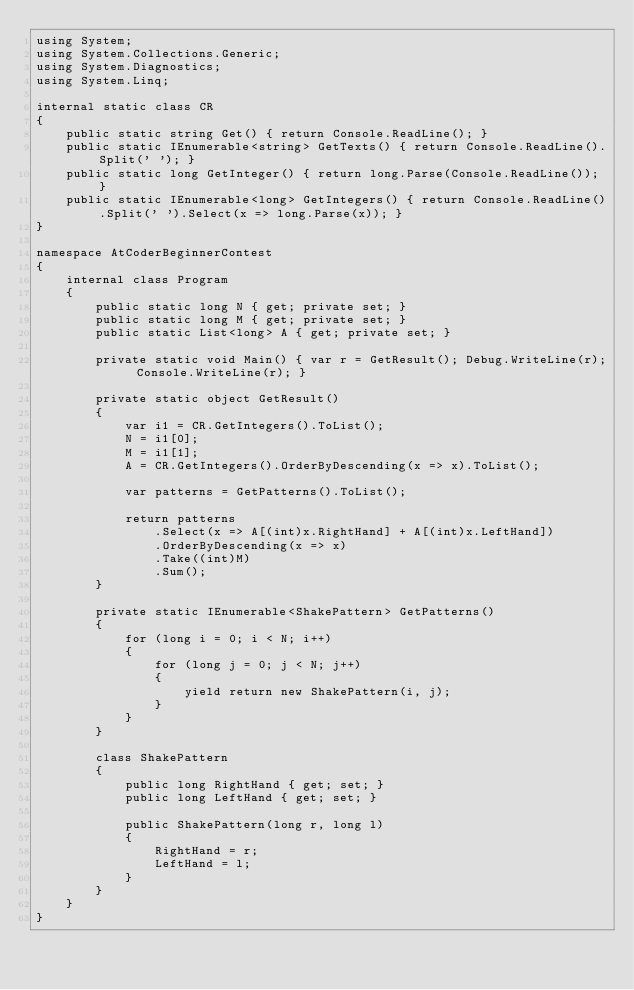<code> <loc_0><loc_0><loc_500><loc_500><_C#_>using System;
using System.Collections.Generic;
using System.Diagnostics;
using System.Linq;

internal static class CR
{
    public static string Get() { return Console.ReadLine(); }
    public static IEnumerable<string> GetTexts() { return Console.ReadLine().Split(' '); }
    public static long GetInteger() { return long.Parse(Console.ReadLine()); }
    public static IEnumerable<long> GetIntegers() { return Console.ReadLine().Split(' ').Select(x => long.Parse(x)); }
}

namespace AtCoderBeginnerContest
{
    internal class Program
    {
        public static long N { get; private set; }
        public static long M { get; private set; }
        public static List<long> A { get; private set; }

        private static void Main() { var r = GetResult(); Debug.WriteLine(r); Console.WriteLine(r); }

        private static object GetResult()
        {
            var i1 = CR.GetIntegers().ToList();
            N = i1[0];
            M = i1[1];
            A = CR.GetIntegers().OrderByDescending(x => x).ToList();

            var patterns = GetPatterns().ToList();

            return patterns
                .Select(x => A[(int)x.RightHand] + A[(int)x.LeftHand])
                .OrderByDescending(x => x)
                .Take((int)M)
                .Sum();
        }

        private static IEnumerable<ShakePattern> GetPatterns()
        {
            for (long i = 0; i < N; i++)
            {
                for (long j = 0; j < N; j++)
                {
                    yield return new ShakePattern(i, j);
                }
            }
        }

        class ShakePattern
        {
            public long RightHand { get; set; }
            public long LeftHand { get; set; }

            public ShakePattern(long r, long l)
            {
                RightHand = r;
                LeftHand = l;
            }
        }
    }
}
</code> 